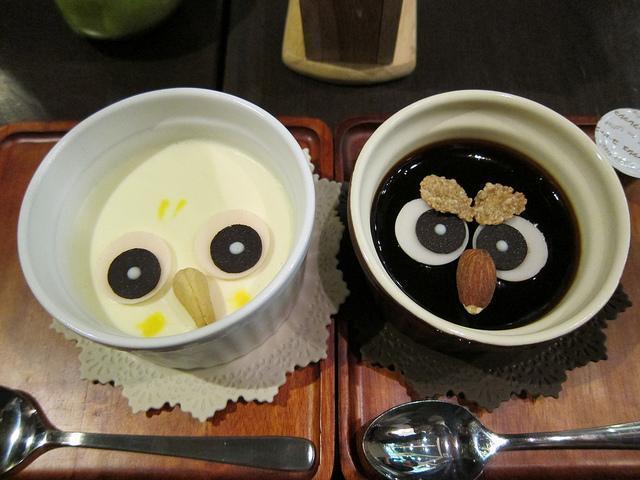How many spoons are there?
Give a very brief answer. 2. How many bowls are visible?
Give a very brief answer. 2. How many baby elephants are there?
Give a very brief answer. 0. 